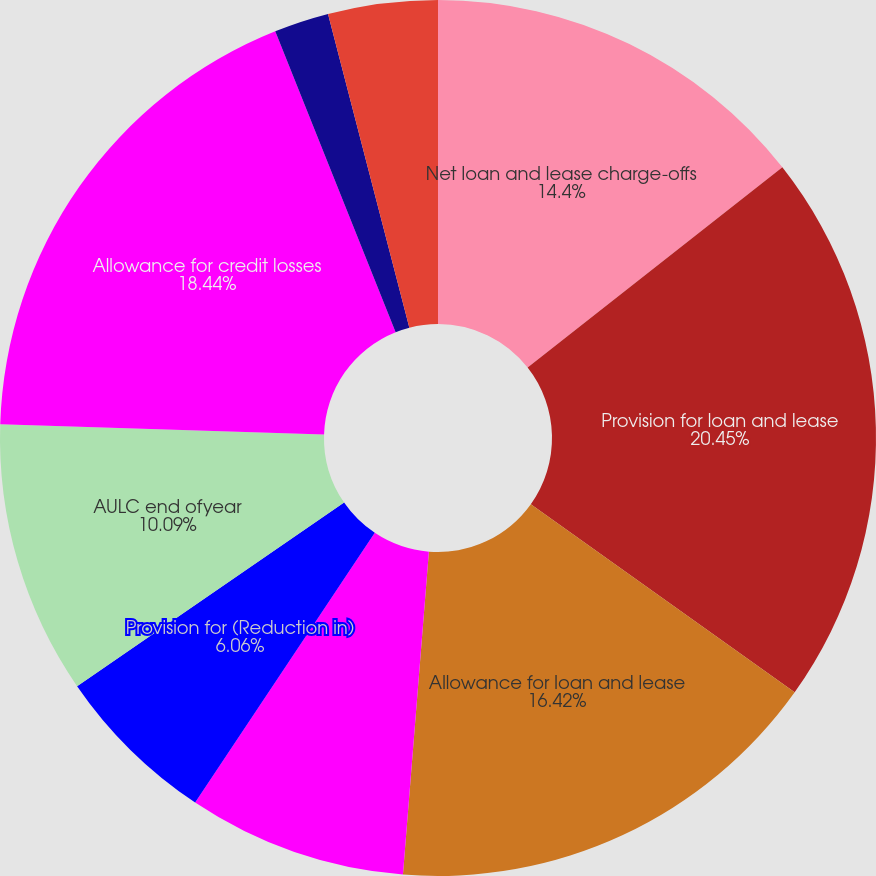Convert chart to OTSL. <chart><loc_0><loc_0><loc_500><loc_500><pie_chart><fcel>Net loan and lease charge-offs<fcel>Provision for loan and lease<fcel>Allowance for loan and lease<fcel>AULC beginning ofyear<fcel>Provision for (Reduction in)<fcel>AULC end ofyear<fcel>Allowance for credit losses<fcel>ALLL as a of total period end<fcel>AULC as a of totalperiod<fcel>ACL as a of total period end<nl><fcel>14.4%<fcel>20.46%<fcel>16.42%<fcel>8.08%<fcel>6.06%<fcel>10.09%<fcel>18.44%<fcel>2.02%<fcel>0.0%<fcel>4.04%<nl></chart> 